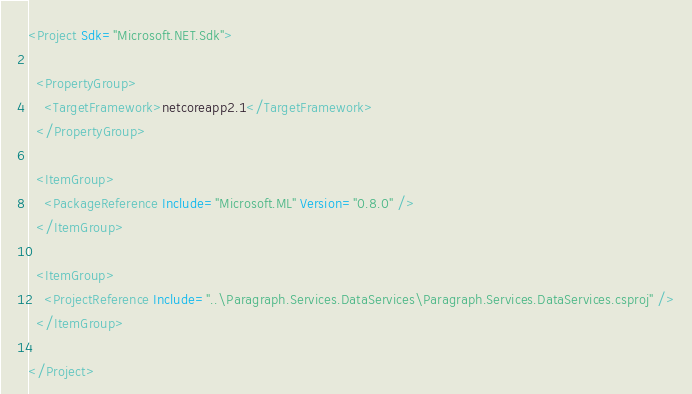<code> <loc_0><loc_0><loc_500><loc_500><_XML_><Project Sdk="Microsoft.NET.Sdk">

  <PropertyGroup>
    <TargetFramework>netcoreapp2.1</TargetFramework>
  </PropertyGroup>

  <ItemGroup>
    <PackageReference Include="Microsoft.ML" Version="0.8.0" />
  </ItemGroup>

  <ItemGroup>
    <ProjectReference Include="..\Paragraph.Services.DataServices\Paragraph.Services.DataServices.csproj" />
  </ItemGroup>

</Project>
</code> 